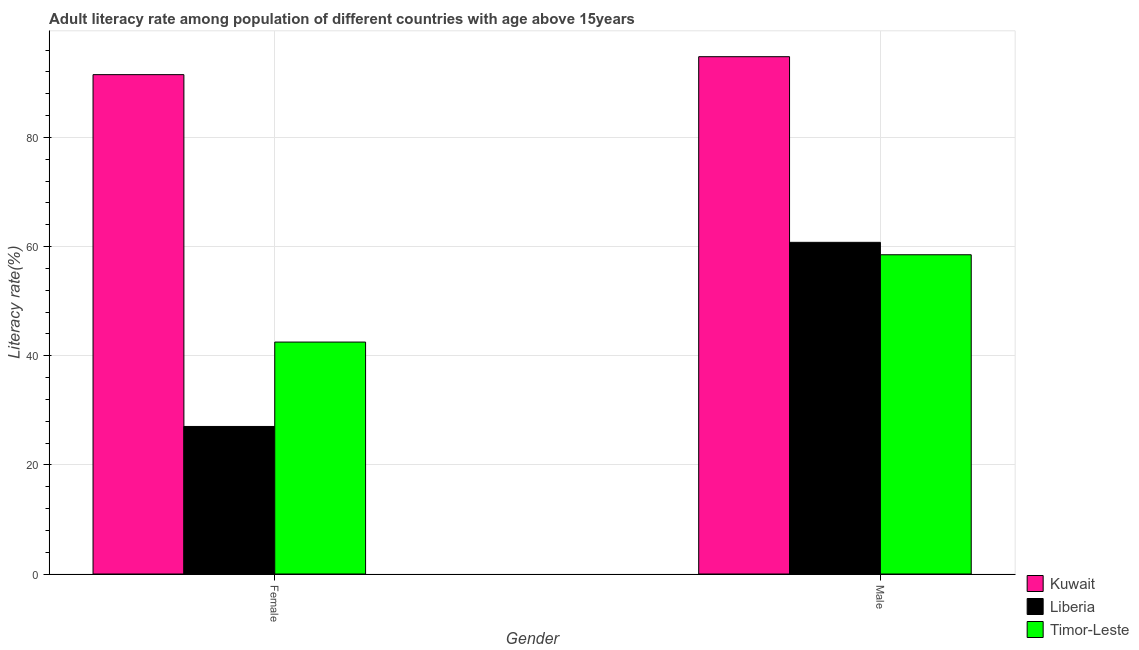How many different coloured bars are there?
Ensure brevity in your answer.  3. Are the number of bars on each tick of the X-axis equal?
Ensure brevity in your answer.  Yes. How many bars are there on the 1st tick from the left?
Your answer should be compact. 3. How many bars are there on the 1st tick from the right?
Make the answer very short. 3. What is the male adult literacy rate in Timor-Leste?
Ensure brevity in your answer.  58.5. Across all countries, what is the maximum male adult literacy rate?
Offer a terse response. 94.79. Across all countries, what is the minimum male adult literacy rate?
Provide a short and direct response. 58.5. In which country was the male adult literacy rate maximum?
Your answer should be very brief. Kuwait. In which country was the male adult literacy rate minimum?
Provide a short and direct response. Timor-Leste. What is the total male adult literacy rate in the graph?
Your response must be concise. 214.07. What is the difference between the female adult literacy rate in Kuwait and that in Timor-Leste?
Make the answer very short. 49. What is the difference between the male adult literacy rate in Kuwait and the female adult literacy rate in Timor-Leste?
Your answer should be compact. 52.29. What is the average male adult literacy rate per country?
Make the answer very short. 71.36. What is the difference between the female adult literacy rate and male adult literacy rate in Kuwait?
Ensure brevity in your answer.  -3.29. What is the ratio of the male adult literacy rate in Timor-Leste to that in Kuwait?
Give a very brief answer. 0.62. Is the male adult literacy rate in Liberia less than that in Timor-Leste?
Your answer should be compact. No. What does the 2nd bar from the left in Male represents?
Make the answer very short. Liberia. What does the 3rd bar from the right in Male represents?
Ensure brevity in your answer.  Kuwait. How many bars are there?
Make the answer very short. 6. Are all the bars in the graph horizontal?
Your answer should be very brief. No. What is the difference between two consecutive major ticks on the Y-axis?
Provide a succinct answer. 20. Where does the legend appear in the graph?
Your answer should be compact. Bottom right. How are the legend labels stacked?
Offer a very short reply. Vertical. What is the title of the graph?
Your answer should be compact. Adult literacy rate among population of different countries with age above 15years. Does "Chile" appear as one of the legend labels in the graph?
Your answer should be compact. No. What is the label or title of the X-axis?
Offer a very short reply. Gender. What is the label or title of the Y-axis?
Give a very brief answer. Literacy rate(%). What is the Literacy rate(%) in Kuwait in Female?
Keep it short and to the point. 91.5. What is the Literacy rate(%) in Liberia in Female?
Offer a terse response. 27.03. What is the Literacy rate(%) in Timor-Leste in Female?
Provide a short and direct response. 42.5. What is the Literacy rate(%) of Kuwait in Male?
Offer a very short reply. 94.79. What is the Literacy rate(%) in Liberia in Male?
Ensure brevity in your answer.  60.77. What is the Literacy rate(%) of Timor-Leste in Male?
Your response must be concise. 58.5. Across all Gender, what is the maximum Literacy rate(%) of Kuwait?
Make the answer very short. 94.79. Across all Gender, what is the maximum Literacy rate(%) in Liberia?
Your answer should be compact. 60.77. Across all Gender, what is the maximum Literacy rate(%) in Timor-Leste?
Give a very brief answer. 58.5. Across all Gender, what is the minimum Literacy rate(%) of Kuwait?
Offer a very short reply. 91.5. Across all Gender, what is the minimum Literacy rate(%) in Liberia?
Give a very brief answer. 27.03. Across all Gender, what is the minimum Literacy rate(%) in Timor-Leste?
Your answer should be compact. 42.5. What is the total Literacy rate(%) of Kuwait in the graph?
Give a very brief answer. 186.3. What is the total Literacy rate(%) of Liberia in the graph?
Your response must be concise. 87.81. What is the total Literacy rate(%) of Timor-Leste in the graph?
Provide a short and direct response. 101. What is the difference between the Literacy rate(%) in Kuwait in Female and that in Male?
Your answer should be compact. -3.29. What is the difference between the Literacy rate(%) in Liberia in Female and that in Male?
Your answer should be compact. -33.74. What is the difference between the Literacy rate(%) in Kuwait in Female and the Literacy rate(%) in Liberia in Male?
Make the answer very short. 30.73. What is the difference between the Literacy rate(%) in Kuwait in Female and the Literacy rate(%) in Timor-Leste in Male?
Your answer should be compact. 33. What is the difference between the Literacy rate(%) in Liberia in Female and the Literacy rate(%) in Timor-Leste in Male?
Keep it short and to the point. -31.47. What is the average Literacy rate(%) of Kuwait per Gender?
Make the answer very short. 93.15. What is the average Literacy rate(%) of Liberia per Gender?
Offer a terse response. 43.9. What is the average Literacy rate(%) in Timor-Leste per Gender?
Make the answer very short. 50.5. What is the difference between the Literacy rate(%) of Kuwait and Literacy rate(%) of Liberia in Female?
Your answer should be compact. 64.47. What is the difference between the Literacy rate(%) in Kuwait and Literacy rate(%) in Timor-Leste in Female?
Provide a short and direct response. 49. What is the difference between the Literacy rate(%) in Liberia and Literacy rate(%) in Timor-Leste in Female?
Ensure brevity in your answer.  -15.47. What is the difference between the Literacy rate(%) of Kuwait and Literacy rate(%) of Liberia in Male?
Your answer should be very brief. 34.02. What is the difference between the Literacy rate(%) in Kuwait and Literacy rate(%) in Timor-Leste in Male?
Offer a terse response. 36.29. What is the difference between the Literacy rate(%) in Liberia and Literacy rate(%) in Timor-Leste in Male?
Offer a very short reply. 2.27. What is the ratio of the Literacy rate(%) in Kuwait in Female to that in Male?
Give a very brief answer. 0.97. What is the ratio of the Literacy rate(%) in Liberia in Female to that in Male?
Your response must be concise. 0.44. What is the ratio of the Literacy rate(%) of Timor-Leste in Female to that in Male?
Your response must be concise. 0.73. What is the difference between the highest and the second highest Literacy rate(%) of Kuwait?
Offer a very short reply. 3.29. What is the difference between the highest and the second highest Literacy rate(%) in Liberia?
Offer a terse response. 33.74. What is the difference between the highest and the second highest Literacy rate(%) of Timor-Leste?
Offer a very short reply. 16. What is the difference between the highest and the lowest Literacy rate(%) of Kuwait?
Offer a very short reply. 3.29. What is the difference between the highest and the lowest Literacy rate(%) in Liberia?
Your answer should be very brief. 33.74. What is the difference between the highest and the lowest Literacy rate(%) in Timor-Leste?
Give a very brief answer. 16. 